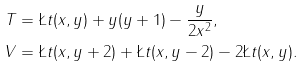Convert formula to latex. <formula><loc_0><loc_0><loc_500><loc_500>T & = \L t ( x , y ) + y ( y + 1 ) - \frac { y } { 2 x ^ { 2 } } , \\ V & = \L t ( x , y + 2 ) + \L t ( x , y - 2 ) - 2 \L t ( x , y ) .</formula> 